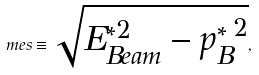Convert formula to latex. <formula><loc_0><loc_0><loc_500><loc_500>\ m e s \equiv \sqrt { { E _ { B e a m } ^ { * 2 } } - { p _ { B } ^ { * } } ^ { 2 } } ,</formula> 